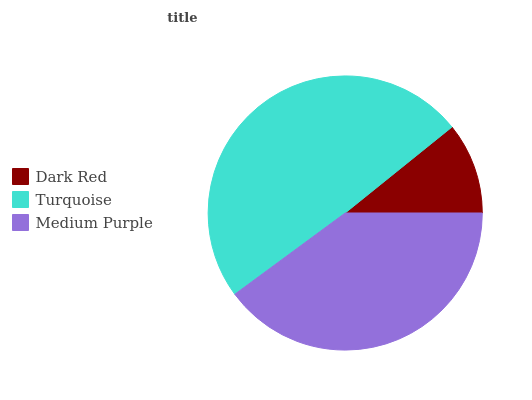Is Dark Red the minimum?
Answer yes or no. Yes. Is Turquoise the maximum?
Answer yes or no. Yes. Is Medium Purple the minimum?
Answer yes or no. No. Is Medium Purple the maximum?
Answer yes or no. No. Is Turquoise greater than Medium Purple?
Answer yes or no. Yes. Is Medium Purple less than Turquoise?
Answer yes or no. Yes. Is Medium Purple greater than Turquoise?
Answer yes or no. No. Is Turquoise less than Medium Purple?
Answer yes or no. No. Is Medium Purple the high median?
Answer yes or no. Yes. Is Medium Purple the low median?
Answer yes or no. Yes. Is Turquoise the high median?
Answer yes or no. No. Is Dark Red the low median?
Answer yes or no. No. 